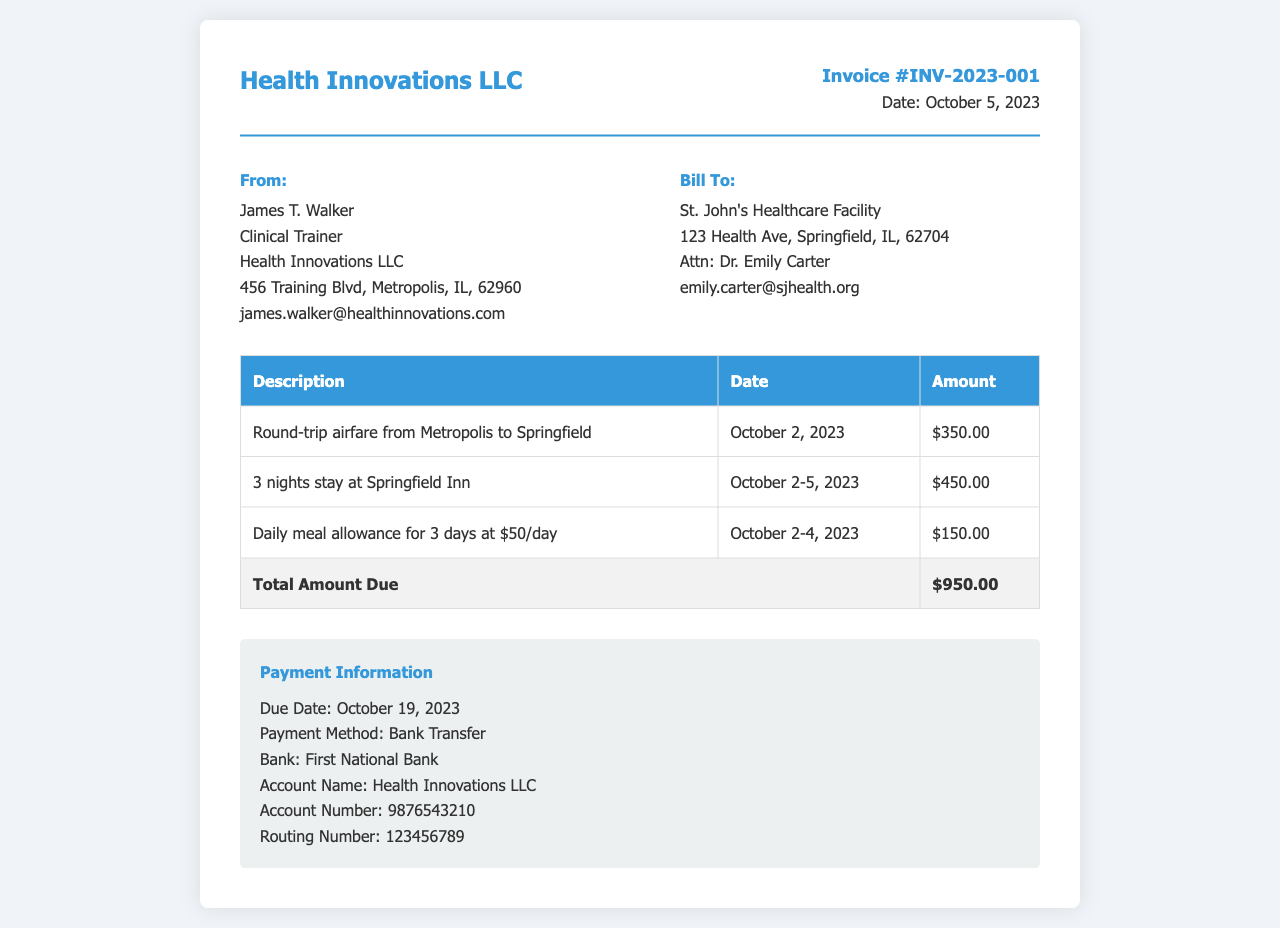What is the invoice number? The invoice number is presented in the document under the invoice details section.
Answer: INV-2023-001 What is the total amount due? The total amount due is found in the table summarizing the expenses.
Answer: $950.00 Who is the clinical trainer? The name of the clinical trainer is listed in the 'From' address section.
Answer: James T. Walker What is the date of the invoice? The date is mentioned in the invoice details section.
Answer: October 5, 2023 How many nights did the stay at Springfield Inn last? The duration of the stay is noted in the table detailing the accommodation costs.
Answer: 3 nights What was the daily meal allowance? The daily meal allowance is specified in the expense breakdown in the document.
Answer: $50/day When is the payment due? The due date for payment is provided in the payment information section.
Answer: October 19, 2023 What payment method is specified? The payment method is indicated in the payment information section.
Answer: Bank Transfer What is the total airfare cost? The airfare cost is detailed in the table listing individual expenses.
Answer: $350.00 